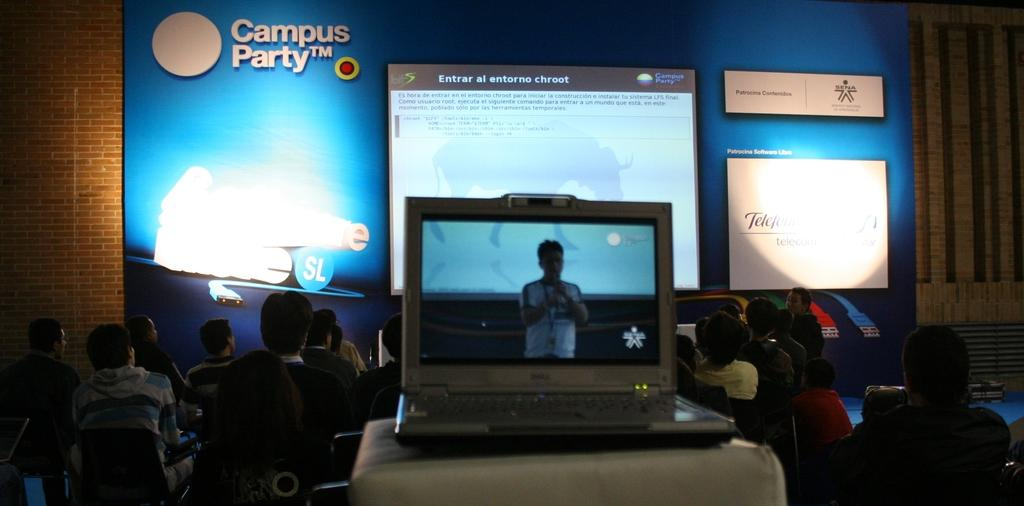<image>
Describe the image concisely. An open laptop is on a stand at the Campus Party conference. 